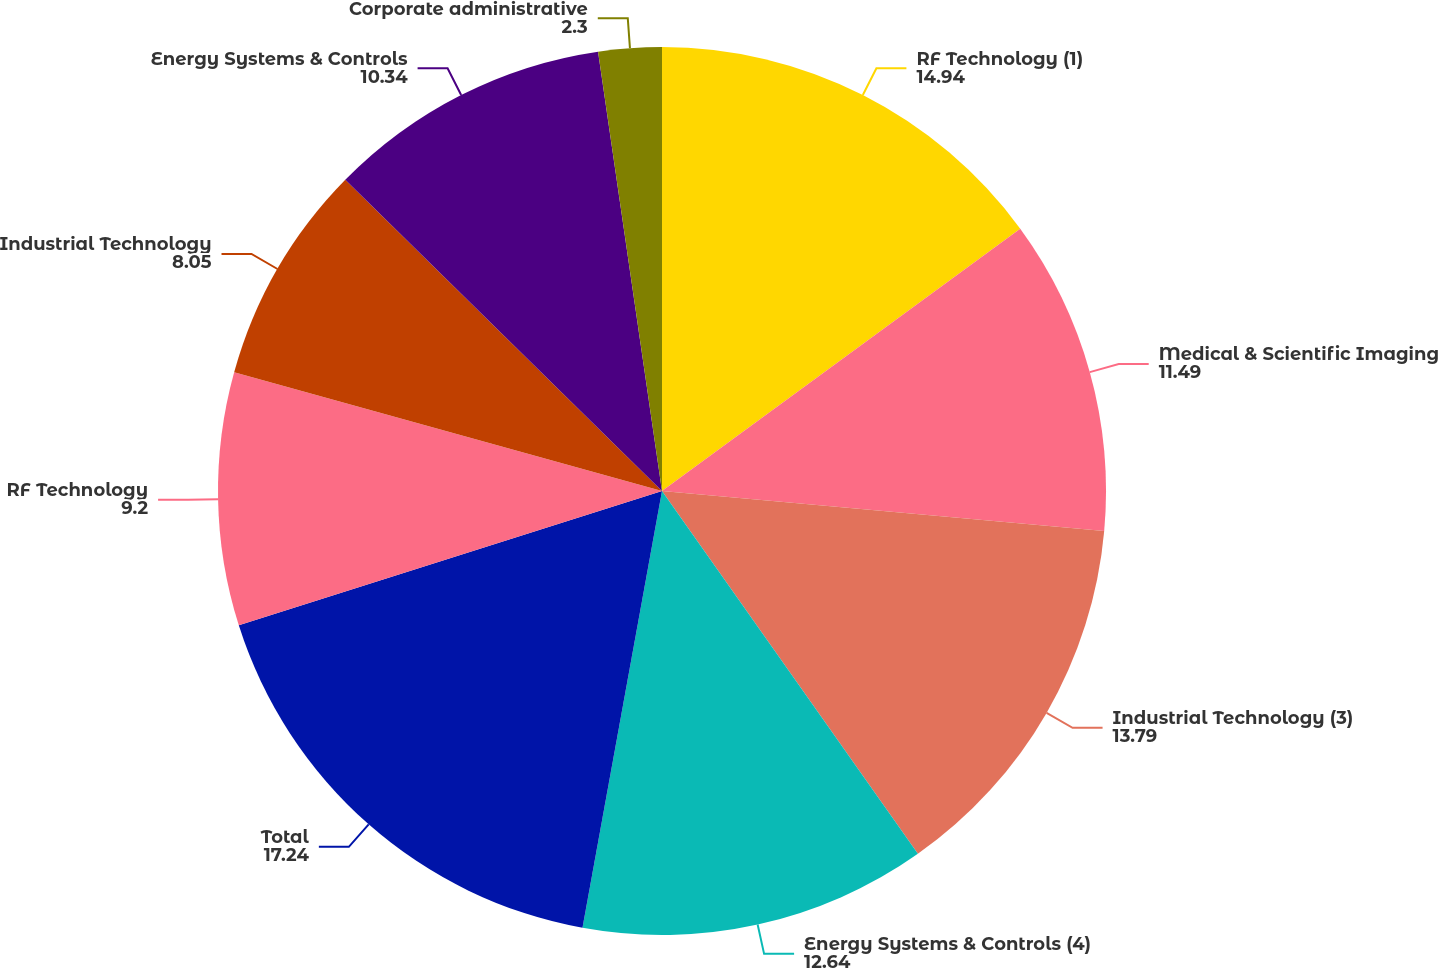Convert chart to OTSL. <chart><loc_0><loc_0><loc_500><loc_500><pie_chart><fcel>RF Technology (1)<fcel>Medical & Scientific Imaging<fcel>Industrial Technology (3)<fcel>Energy Systems & Controls (4)<fcel>Total<fcel>RF Technology<fcel>Industrial Technology<fcel>Energy Systems & Controls<fcel>Corporate administrative<nl><fcel>14.94%<fcel>11.49%<fcel>13.79%<fcel>12.64%<fcel>17.24%<fcel>9.2%<fcel>8.05%<fcel>10.34%<fcel>2.3%<nl></chart> 